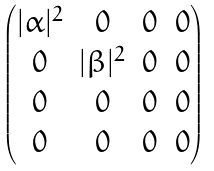Convert formula to latex. <formula><loc_0><loc_0><loc_500><loc_500>\begin{pmatrix} | \alpha | ^ { 2 } & 0 & 0 & 0 \\ 0 & | \beta | ^ { 2 } & 0 & 0 \\ 0 & 0 & 0 & 0 \\ 0 & 0 & 0 & 0 \end{pmatrix}</formula> 